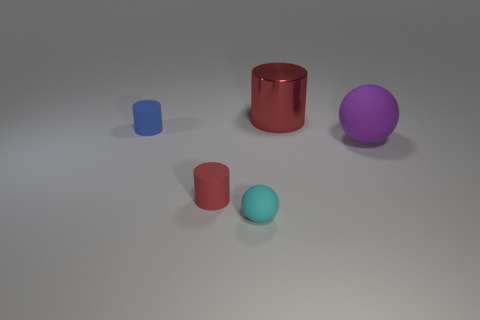Subtract all red cylinders. How many cylinders are left? 1 Add 1 rubber objects. How many objects exist? 6 Subtract all brown cubes. How many red cylinders are left? 2 Subtract all blue cylinders. How many cylinders are left? 2 Subtract 1 cylinders. How many cylinders are left? 2 Add 4 small blue rubber objects. How many small blue rubber objects are left? 5 Add 3 small red rubber things. How many small red rubber things exist? 4 Subtract 0 blue balls. How many objects are left? 5 Subtract all cylinders. How many objects are left? 2 Subtract all red cylinders. Subtract all blue blocks. How many cylinders are left? 1 